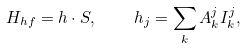<formula> <loc_0><loc_0><loc_500><loc_500>H _ { h f } = h \cdot S , \quad h _ { j } = \sum _ { k } A _ { k } ^ { j } I _ { k } ^ { j } ,</formula> 